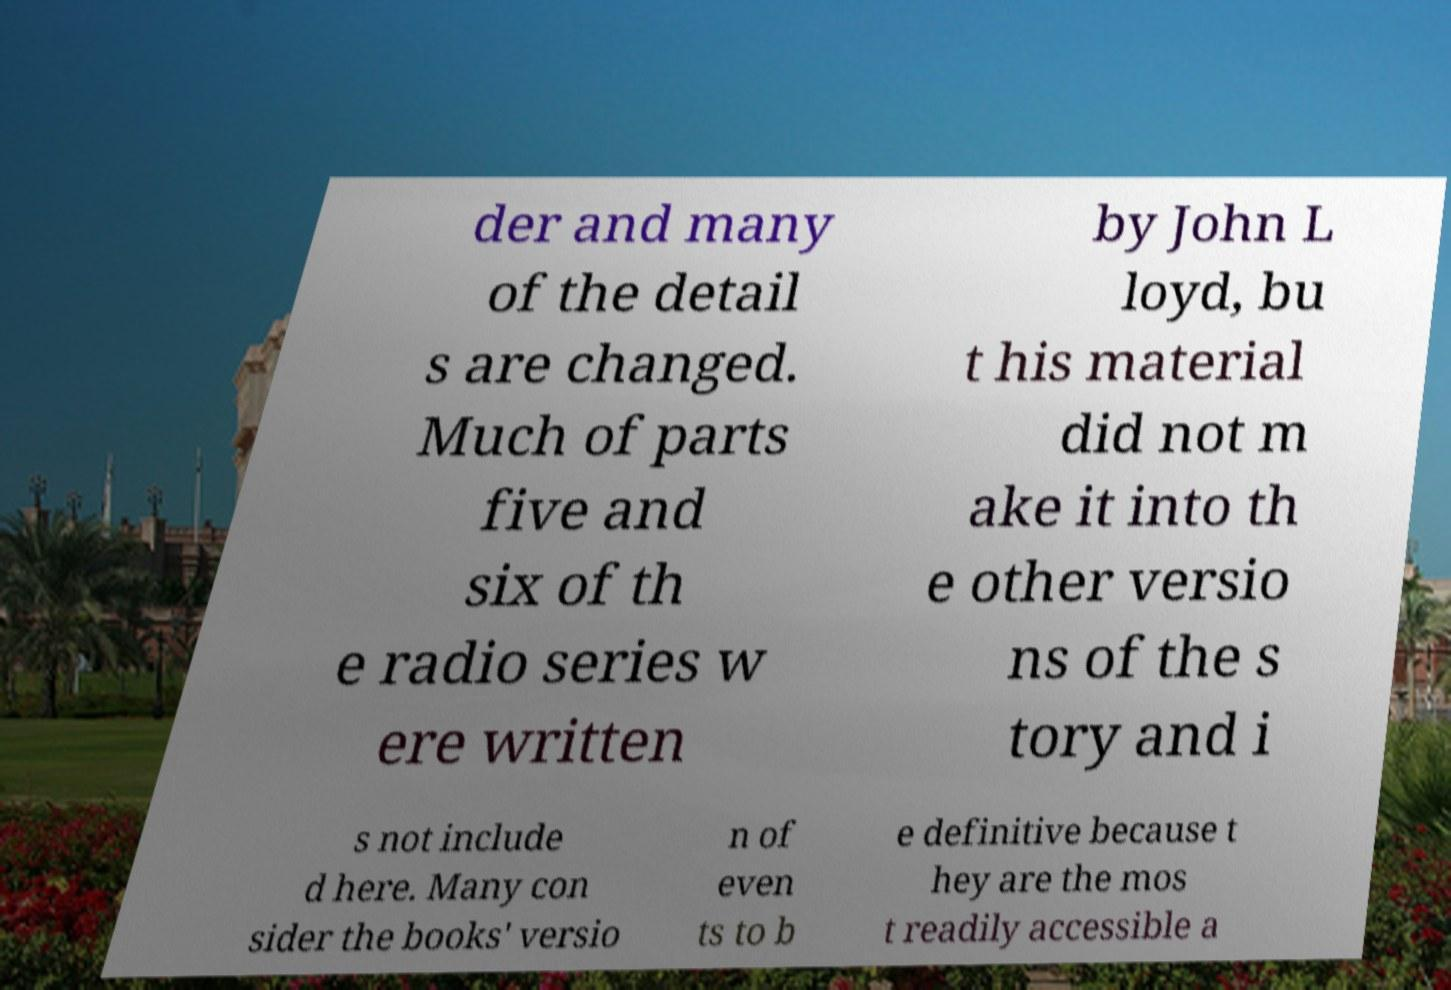For documentation purposes, I need the text within this image transcribed. Could you provide that? der and many of the detail s are changed. Much of parts five and six of th e radio series w ere written by John L loyd, bu t his material did not m ake it into th e other versio ns of the s tory and i s not include d here. Many con sider the books' versio n of even ts to b e definitive because t hey are the mos t readily accessible a 